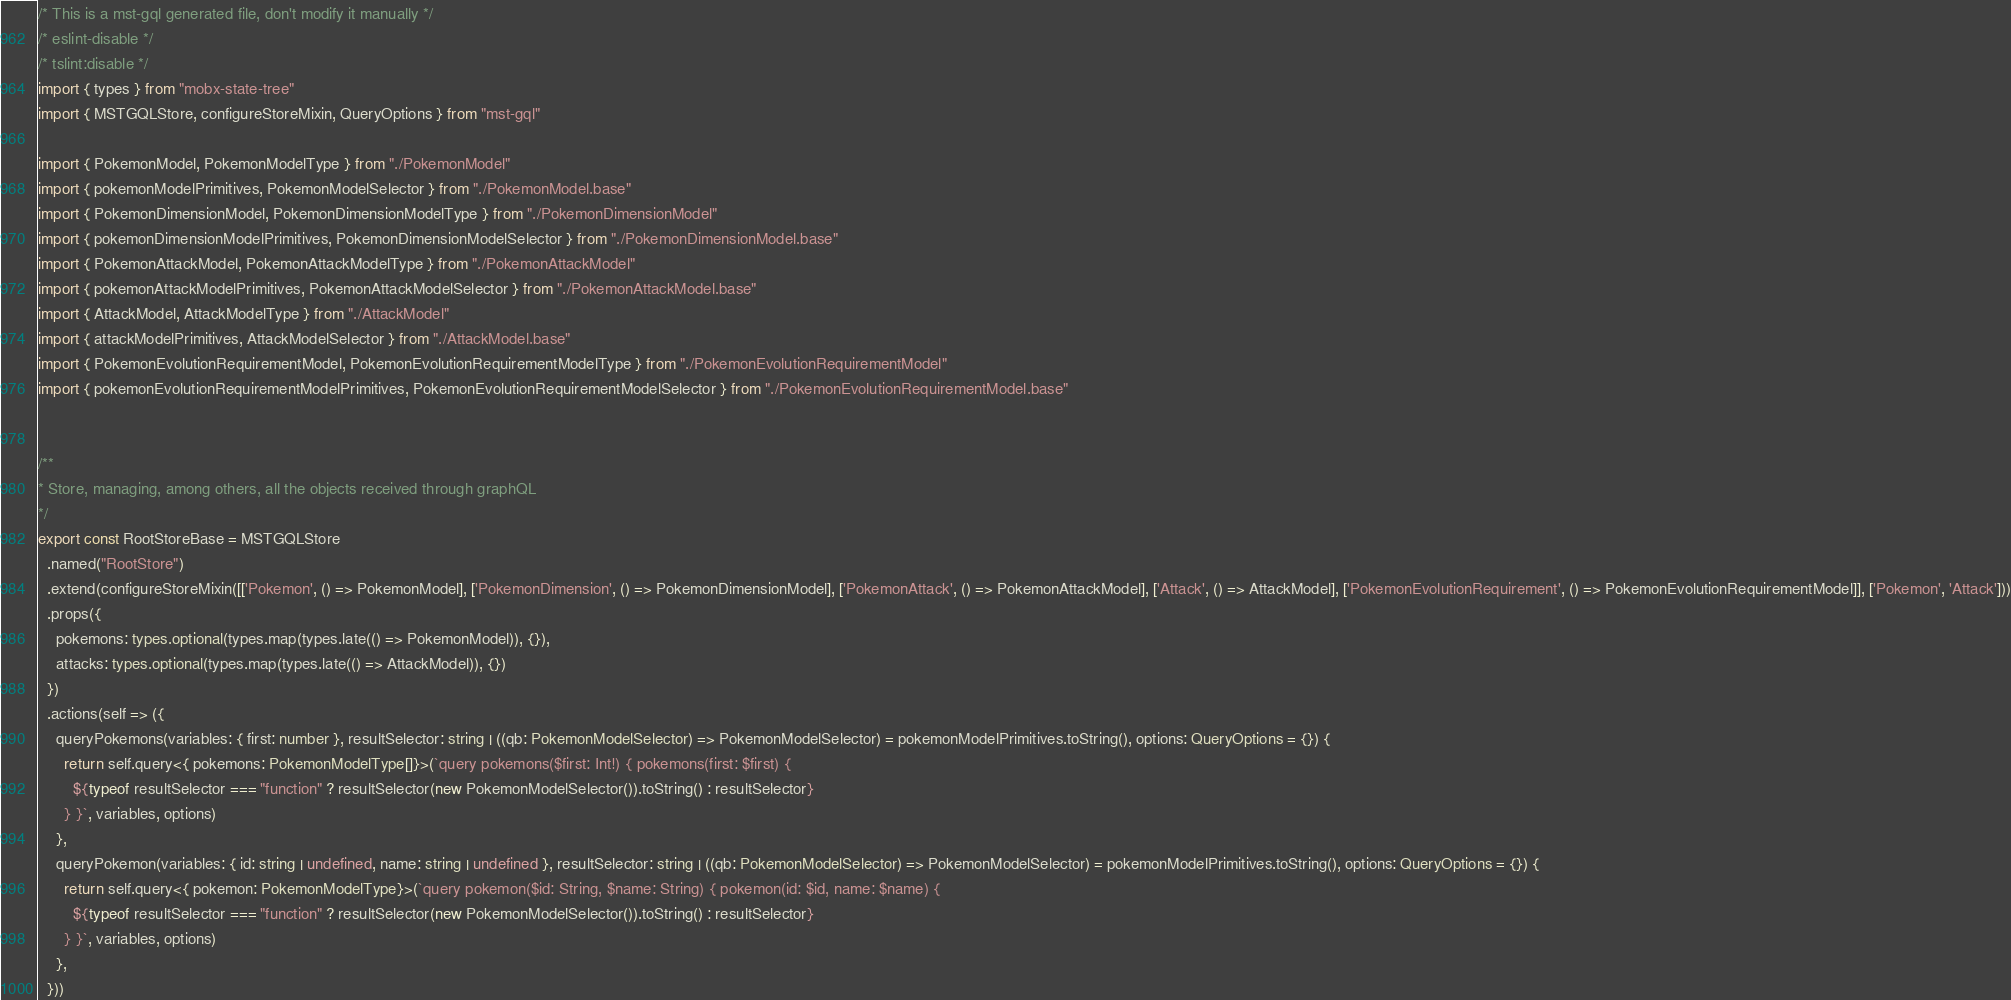<code> <loc_0><loc_0><loc_500><loc_500><_TypeScript_>/* This is a mst-gql generated file, don't modify it manually */
/* eslint-disable */
/* tslint:disable */
import { types } from "mobx-state-tree"
import { MSTGQLStore, configureStoreMixin, QueryOptions } from "mst-gql"

import { PokemonModel, PokemonModelType } from "./PokemonModel"
import { pokemonModelPrimitives, PokemonModelSelector } from "./PokemonModel.base"
import { PokemonDimensionModel, PokemonDimensionModelType } from "./PokemonDimensionModel"
import { pokemonDimensionModelPrimitives, PokemonDimensionModelSelector } from "./PokemonDimensionModel.base"
import { PokemonAttackModel, PokemonAttackModelType } from "./PokemonAttackModel"
import { pokemonAttackModelPrimitives, PokemonAttackModelSelector } from "./PokemonAttackModel.base"
import { AttackModel, AttackModelType } from "./AttackModel"
import { attackModelPrimitives, AttackModelSelector } from "./AttackModel.base"
import { PokemonEvolutionRequirementModel, PokemonEvolutionRequirementModelType } from "./PokemonEvolutionRequirementModel"
import { pokemonEvolutionRequirementModelPrimitives, PokemonEvolutionRequirementModelSelector } from "./PokemonEvolutionRequirementModel.base"


/**
* Store, managing, among others, all the objects received through graphQL
*/
export const RootStoreBase = MSTGQLStore
  .named("RootStore")
  .extend(configureStoreMixin([['Pokemon', () => PokemonModel], ['PokemonDimension', () => PokemonDimensionModel], ['PokemonAttack', () => PokemonAttackModel], ['Attack', () => AttackModel], ['PokemonEvolutionRequirement', () => PokemonEvolutionRequirementModel]], ['Pokemon', 'Attack']))
  .props({
    pokemons: types.optional(types.map(types.late(() => PokemonModel)), {}),
    attacks: types.optional(types.map(types.late(() => AttackModel)), {})
  })
  .actions(self => ({
    queryPokemons(variables: { first: number }, resultSelector: string | ((qb: PokemonModelSelector) => PokemonModelSelector) = pokemonModelPrimitives.toString(), options: QueryOptions = {}) {
      return self.query<{ pokemons: PokemonModelType[]}>(`query pokemons($first: Int!) { pokemons(first: $first) {
        ${typeof resultSelector === "function" ? resultSelector(new PokemonModelSelector()).toString() : resultSelector}
      } }`, variables, options)
    },
    queryPokemon(variables: { id: string | undefined, name: string | undefined }, resultSelector: string | ((qb: PokemonModelSelector) => PokemonModelSelector) = pokemonModelPrimitives.toString(), options: QueryOptions = {}) {
      return self.query<{ pokemon: PokemonModelType}>(`query pokemon($id: String, $name: String) { pokemon(id: $id, name: $name) {
        ${typeof resultSelector === "function" ? resultSelector(new PokemonModelSelector()).toString() : resultSelector}
      } }`, variables, options)
    },
  }))
</code> 